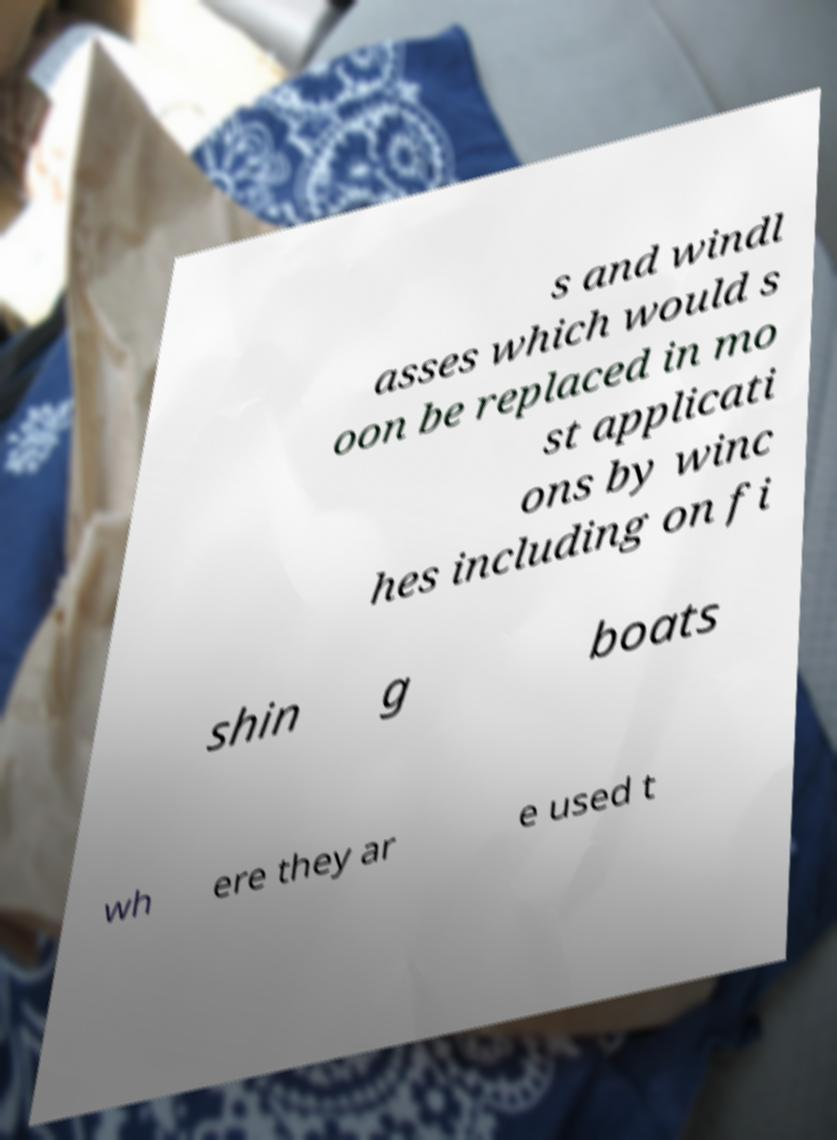Could you assist in decoding the text presented in this image and type it out clearly? s and windl asses which would s oon be replaced in mo st applicati ons by winc hes including on fi shin g boats wh ere they ar e used t 